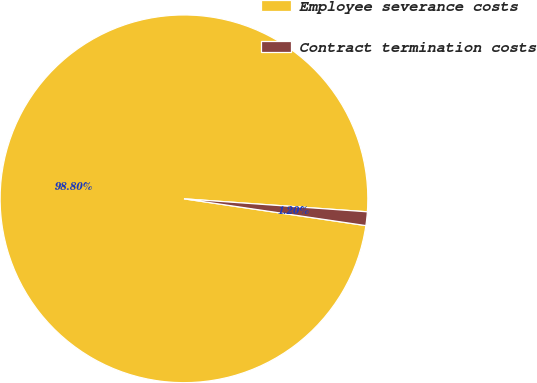Convert chart to OTSL. <chart><loc_0><loc_0><loc_500><loc_500><pie_chart><fcel>Employee severance costs<fcel>Contract termination costs<nl><fcel>98.8%<fcel>1.2%<nl></chart> 